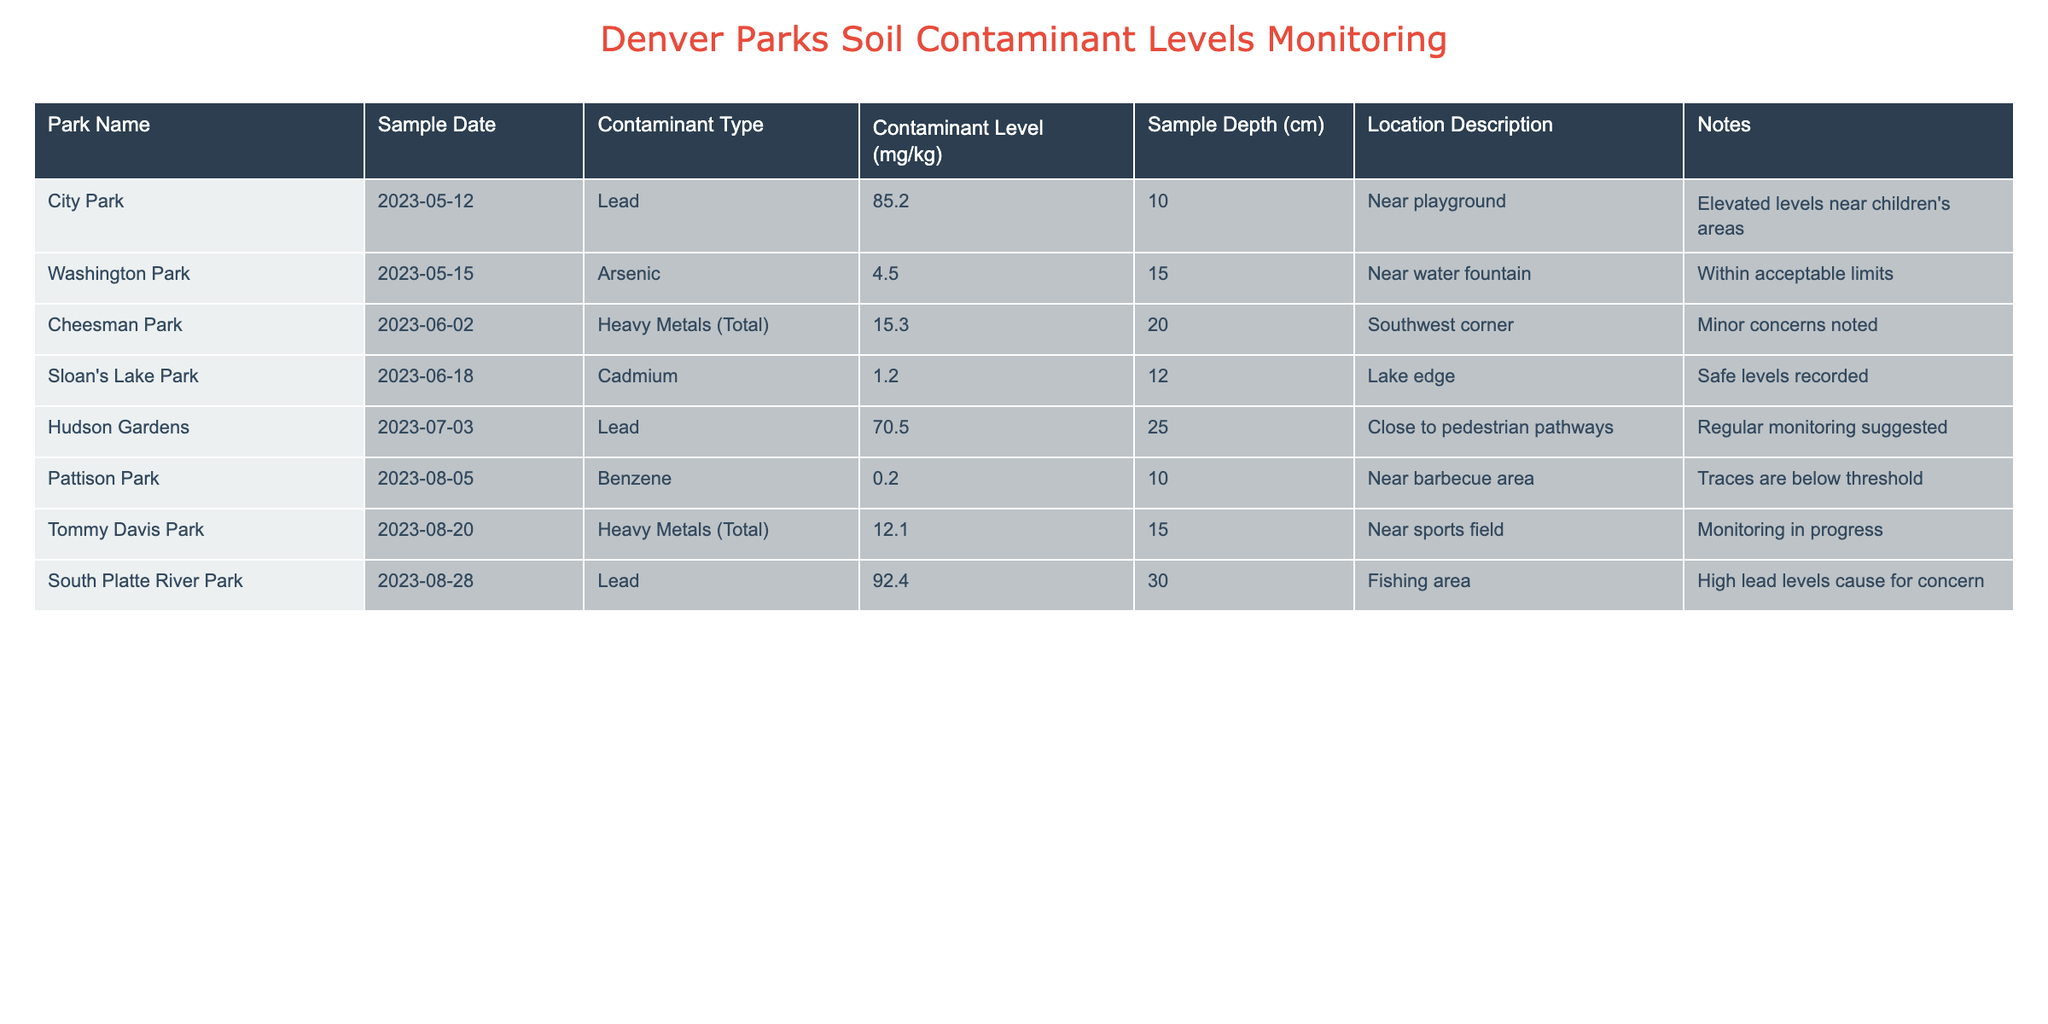What is the contaminant level of Lead in City Park? The table shows a contaminant level of 85.2 mg/kg for Lead in City Park as recorded on May 12, 2023.
Answer: 85.2 mg/kg Which park has the highest level of Lead? The table lists South Platte River Park with a Lead level of 92.4 mg/kg, which is higher than the levels measured in City Park and Hudson Gardens.
Answer: South Platte River Park Is the level of Arsenic in Washington Park within acceptable limits? The table indicates an Arsenic level of 4.5 mg/kg in Washington Park as recorded on May 15, 2023. This is noted as being within acceptable limits.
Answer: Yes What are the contaminant levels of Heavy Metals (Total) in both Cheesman Park and Tommy Davis Park, and which park has a higher level? Cheesman Park has a Heavy Metals (Total) level of 15.3 mg/kg, while Tommy Davis Park has a level of 12.1 mg/kg. Comparing these values, Cheesman Park is higher.
Answer: Cheesman Park How many parks have Lead levels above 70 mg/kg? City Park (85.2 mg/kg) and South Platte River Park (92.4 mg/kg) are the two parks with Lead levels above 70 mg/kg.
Answer: 2 parks What is the average contaminant level for Cadmium across all parks? The only park with a Cadmium measurement is Sloan's Lake Park, which has a level of 1.2 mg/kg. Since there is only a single measurement, the average will also be 1.2 mg/kg.
Answer: 1.2 mg/kg Does any park have a contaminant level for Benzene that is above the threshold? The table shows 0.2 mg/kg of Benzene in Pattison Park, which is labeled as below the threshold, indicating it is safe.
Answer: No Which park recorded the lowest level of Heavy Metals (Total)? The Heavy Metals (Total) levels recorded are 15.3 mg/kg in Cheesman Park and 12.1 mg/kg in Tommy Davis Park. Therefore, Tommy Davis Park has the lowest level.
Answer: Tommy Davis Park 